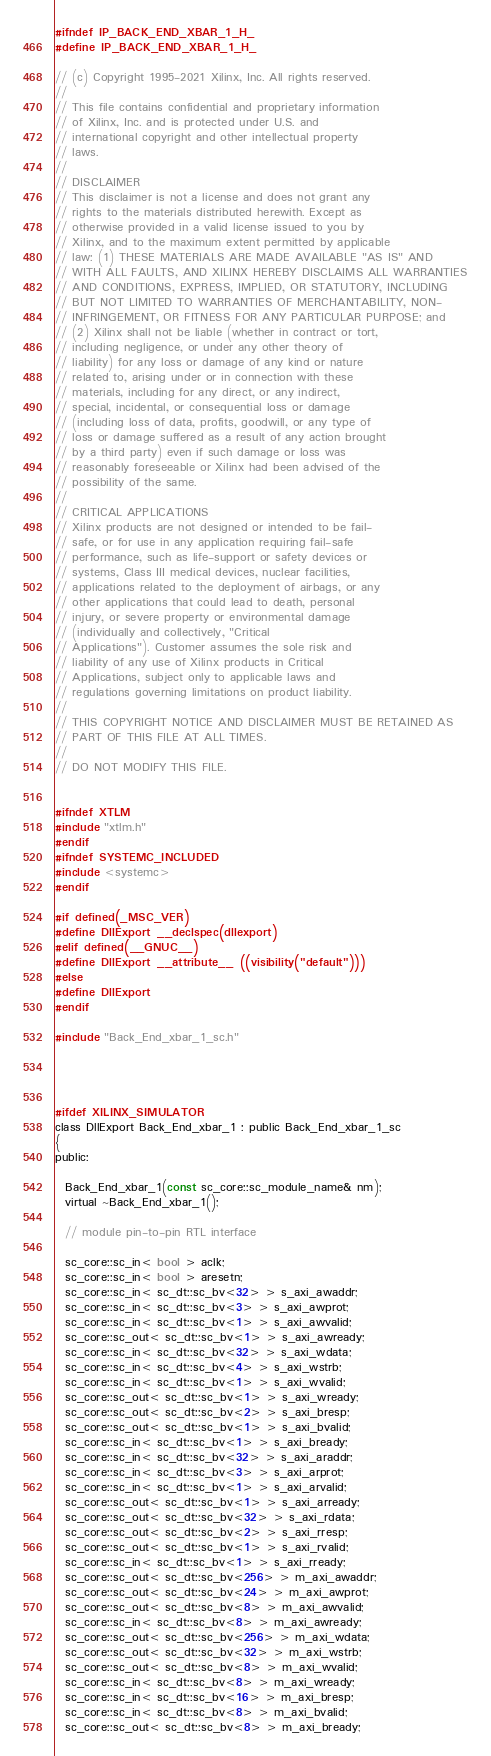<code> <loc_0><loc_0><loc_500><loc_500><_C_>#ifndef IP_BACK_END_XBAR_1_H_
#define IP_BACK_END_XBAR_1_H_

// (c) Copyright 1995-2021 Xilinx, Inc. All rights reserved.
// 
// This file contains confidential and proprietary information
// of Xilinx, Inc. and is protected under U.S. and
// international copyright and other intellectual property
// laws.
// 
// DISCLAIMER
// This disclaimer is not a license and does not grant any
// rights to the materials distributed herewith. Except as
// otherwise provided in a valid license issued to you by
// Xilinx, and to the maximum extent permitted by applicable
// law: (1) THESE MATERIALS ARE MADE AVAILABLE "AS IS" AND
// WITH ALL FAULTS, AND XILINX HEREBY DISCLAIMS ALL WARRANTIES
// AND CONDITIONS, EXPRESS, IMPLIED, OR STATUTORY, INCLUDING
// BUT NOT LIMITED TO WARRANTIES OF MERCHANTABILITY, NON-
// INFRINGEMENT, OR FITNESS FOR ANY PARTICULAR PURPOSE; and
// (2) Xilinx shall not be liable (whether in contract or tort,
// including negligence, or under any other theory of
// liability) for any loss or damage of any kind or nature
// related to, arising under or in connection with these
// materials, including for any direct, or any indirect,
// special, incidental, or consequential loss or damage
// (including loss of data, profits, goodwill, or any type of
// loss or damage suffered as a result of any action brought
// by a third party) even if such damage or loss was
// reasonably foreseeable or Xilinx had been advised of the
// possibility of the same.
// 
// CRITICAL APPLICATIONS
// Xilinx products are not designed or intended to be fail-
// safe, or for use in any application requiring fail-safe
// performance, such as life-support or safety devices or
// systems, Class III medical devices, nuclear facilities,
// applications related to the deployment of airbags, or any
// other applications that could lead to death, personal
// injury, or severe property or environmental damage
// (individually and collectively, "Critical
// Applications"). Customer assumes the sole risk and
// liability of any use of Xilinx products in Critical
// Applications, subject only to applicable laws and
// regulations governing limitations on product liability.
// 
// THIS COPYRIGHT NOTICE AND DISCLAIMER MUST BE RETAINED AS
// PART OF THIS FILE AT ALL TIMES.
// 
// DO NOT MODIFY THIS FILE.


#ifndef XTLM
#include "xtlm.h"
#endif
#ifndef SYSTEMC_INCLUDED
#include <systemc>
#endif

#if defined(_MSC_VER)
#define DllExport __declspec(dllexport)
#elif defined(__GNUC__)
#define DllExport __attribute__ ((visibility("default")))
#else
#define DllExport
#endif

#include "Back_End_xbar_1_sc.h"




#ifdef XILINX_SIMULATOR
class DllExport Back_End_xbar_1 : public Back_End_xbar_1_sc
{
public:

  Back_End_xbar_1(const sc_core::sc_module_name& nm);
  virtual ~Back_End_xbar_1();

  // module pin-to-pin RTL interface

  sc_core::sc_in< bool > aclk;
  sc_core::sc_in< bool > aresetn;
  sc_core::sc_in< sc_dt::sc_bv<32> > s_axi_awaddr;
  sc_core::sc_in< sc_dt::sc_bv<3> > s_axi_awprot;
  sc_core::sc_in< sc_dt::sc_bv<1> > s_axi_awvalid;
  sc_core::sc_out< sc_dt::sc_bv<1> > s_axi_awready;
  sc_core::sc_in< sc_dt::sc_bv<32> > s_axi_wdata;
  sc_core::sc_in< sc_dt::sc_bv<4> > s_axi_wstrb;
  sc_core::sc_in< sc_dt::sc_bv<1> > s_axi_wvalid;
  sc_core::sc_out< sc_dt::sc_bv<1> > s_axi_wready;
  sc_core::sc_out< sc_dt::sc_bv<2> > s_axi_bresp;
  sc_core::sc_out< sc_dt::sc_bv<1> > s_axi_bvalid;
  sc_core::sc_in< sc_dt::sc_bv<1> > s_axi_bready;
  sc_core::sc_in< sc_dt::sc_bv<32> > s_axi_araddr;
  sc_core::sc_in< sc_dt::sc_bv<3> > s_axi_arprot;
  sc_core::sc_in< sc_dt::sc_bv<1> > s_axi_arvalid;
  sc_core::sc_out< sc_dt::sc_bv<1> > s_axi_arready;
  sc_core::sc_out< sc_dt::sc_bv<32> > s_axi_rdata;
  sc_core::sc_out< sc_dt::sc_bv<2> > s_axi_rresp;
  sc_core::sc_out< sc_dt::sc_bv<1> > s_axi_rvalid;
  sc_core::sc_in< sc_dt::sc_bv<1> > s_axi_rready;
  sc_core::sc_out< sc_dt::sc_bv<256> > m_axi_awaddr;
  sc_core::sc_out< sc_dt::sc_bv<24> > m_axi_awprot;
  sc_core::sc_out< sc_dt::sc_bv<8> > m_axi_awvalid;
  sc_core::sc_in< sc_dt::sc_bv<8> > m_axi_awready;
  sc_core::sc_out< sc_dt::sc_bv<256> > m_axi_wdata;
  sc_core::sc_out< sc_dt::sc_bv<32> > m_axi_wstrb;
  sc_core::sc_out< sc_dt::sc_bv<8> > m_axi_wvalid;
  sc_core::sc_in< sc_dt::sc_bv<8> > m_axi_wready;
  sc_core::sc_in< sc_dt::sc_bv<16> > m_axi_bresp;
  sc_core::sc_in< sc_dt::sc_bv<8> > m_axi_bvalid;
  sc_core::sc_out< sc_dt::sc_bv<8> > m_axi_bready;</code> 